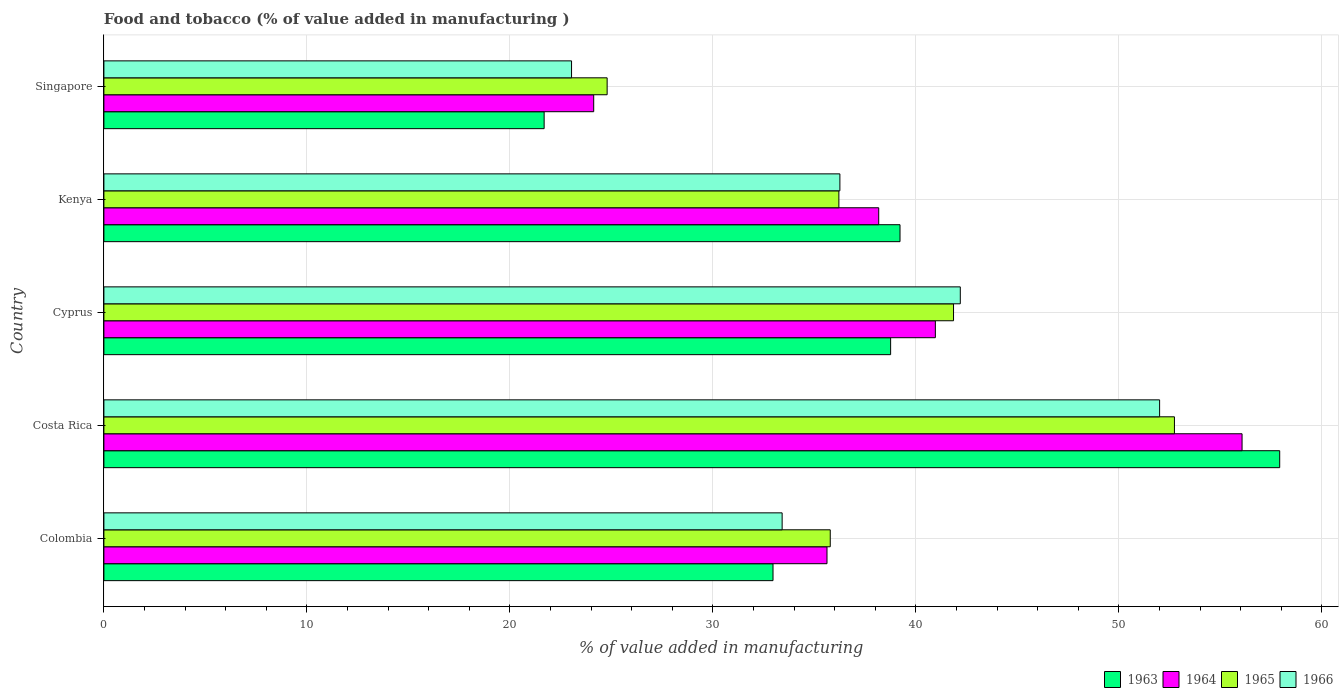How many groups of bars are there?
Provide a short and direct response. 5. How many bars are there on the 3rd tick from the top?
Keep it short and to the point. 4. How many bars are there on the 3rd tick from the bottom?
Provide a short and direct response. 4. What is the label of the 5th group of bars from the top?
Offer a very short reply. Colombia. In how many cases, is the number of bars for a given country not equal to the number of legend labels?
Offer a very short reply. 0. What is the value added in manufacturing food and tobacco in 1965 in Costa Rica?
Your answer should be compact. 52.73. Across all countries, what is the maximum value added in manufacturing food and tobacco in 1965?
Your answer should be compact. 52.73. Across all countries, what is the minimum value added in manufacturing food and tobacco in 1965?
Provide a short and direct response. 24.79. In which country was the value added in manufacturing food and tobacco in 1966 maximum?
Ensure brevity in your answer.  Costa Rica. In which country was the value added in manufacturing food and tobacco in 1963 minimum?
Your answer should be compact. Singapore. What is the total value added in manufacturing food and tobacco in 1963 in the graph?
Your answer should be compact. 190.54. What is the difference between the value added in manufacturing food and tobacco in 1965 in Colombia and that in Cyprus?
Offer a very short reply. -6.07. What is the difference between the value added in manufacturing food and tobacco in 1966 in Kenya and the value added in manufacturing food and tobacco in 1963 in Singapore?
Make the answer very short. 14.57. What is the average value added in manufacturing food and tobacco in 1965 per country?
Offer a terse response. 38.27. What is the difference between the value added in manufacturing food and tobacco in 1966 and value added in manufacturing food and tobacco in 1963 in Colombia?
Provide a succinct answer. 0.45. In how many countries, is the value added in manufacturing food and tobacco in 1963 greater than 46 %?
Your answer should be compact. 1. What is the ratio of the value added in manufacturing food and tobacco in 1965 in Colombia to that in Singapore?
Make the answer very short. 1.44. What is the difference between the highest and the second highest value added in manufacturing food and tobacco in 1966?
Offer a terse response. 9.82. What is the difference between the highest and the lowest value added in manufacturing food and tobacco in 1966?
Give a very brief answer. 28.97. What does the 2nd bar from the top in Costa Rica represents?
Ensure brevity in your answer.  1965. What does the 3rd bar from the bottom in Singapore represents?
Provide a succinct answer. 1965. Is it the case that in every country, the sum of the value added in manufacturing food and tobacco in 1966 and value added in manufacturing food and tobacco in 1963 is greater than the value added in manufacturing food and tobacco in 1964?
Ensure brevity in your answer.  Yes. How many countries are there in the graph?
Your response must be concise. 5. Are the values on the major ticks of X-axis written in scientific E-notation?
Offer a very short reply. No. Does the graph contain any zero values?
Your response must be concise. No. Does the graph contain grids?
Ensure brevity in your answer.  Yes. How are the legend labels stacked?
Give a very brief answer. Horizontal. What is the title of the graph?
Ensure brevity in your answer.  Food and tobacco (% of value added in manufacturing ). What is the label or title of the X-axis?
Ensure brevity in your answer.  % of value added in manufacturing. What is the label or title of the Y-axis?
Offer a terse response. Country. What is the % of value added in manufacturing of 1963 in Colombia?
Give a very brief answer. 32.96. What is the % of value added in manufacturing in 1964 in Colombia?
Provide a succinct answer. 35.62. What is the % of value added in manufacturing of 1965 in Colombia?
Offer a terse response. 35.78. What is the % of value added in manufacturing in 1966 in Colombia?
Your answer should be compact. 33.41. What is the % of value added in manufacturing of 1963 in Costa Rica?
Ensure brevity in your answer.  57.92. What is the % of value added in manufacturing of 1964 in Costa Rica?
Provide a short and direct response. 56.07. What is the % of value added in manufacturing of 1965 in Costa Rica?
Offer a very short reply. 52.73. What is the % of value added in manufacturing in 1966 in Costa Rica?
Provide a short and direct response. 52. What is the % of value added in manufacturing of 1963 in Cyprus?
Your answer should be very brief. 38.75. What is the % of value added in manufacturing of 1964 in Cyprus?
Your response must be concise. 40.96. What is the % of value added in manufacturing of 1965 in Cyprus?
Provide a succinct answer. 41.85. What is the % of value added in manufacturing in 1966 in Cyprus?
Provide a short and direct response. 42.19. What is the % of value added in manufacturing of 1963 in Kenya?
Provide a succinct answer. 39.22. What is the % of value added in manufacturing in 1964 in Kenya?
Your answer should be very brief. 38.17. What is the % of value added in manufacturing in 1965 in Kenya?
Give a very brief answer. 36.2. What is the % of value added in manufacturing in 1966 in Kenya?
Keep it short and to the point. 36.25. What is the % of value added in manufacturing in 1963 in Singapore?
Offer a terse response. 21.69. What is the % of value added in manufacturing of 1964 in Singapore?
Provide a succinct answer. 24.13. What is the % of value added in manufacturing in 1965 in Singapore?
Keep it short and to the point. 24.79. What is the % of value added in manufacturing of 1966 in Singapore?
Provide a succinct answer. 23.04. Across all countries, what is the maximum % of value added in manufacturing in 1963?
Offer a terse response. 57.92. Across all countries, what is the maximum % of value added in manufacturing of 1964?
Make the answer very short. 56.07. Across all countries, what is the maximum % of value added in manufacturing of 1965?
Provide a succinct answer. 52.73. Across all countries, what is the maximum % of value added in manufacturing in 1966?
Give a very brief answer. 52. Across all countries, what is the minimum % of value added in manufacturing in 1963?
Your response must be concise. 21.69. Across all countries, what is the minimum % of value added in manufacturing of 1964?
Provide a short and direct response. 24.13. Across all countries, what is the minimum % of value added in manufacturing in 1965?
Provide a succinct answer. 24.79. Across all countries, what is the minimum % of value added in manufacturing of 1966?
Offer a very short reply. 23.04. What is the total % of value added in manufacturing of 1963 in the graph?
Make the answer very short. 190.54. What is the total % of value added in manufacturing in 1964 in the graph?
Offer a very short reply. 194.94. What is the total % of value added in manufacturing in 1965 in the graph?
Give a very brief answer. 191.36. What is the total % of value added in manufacturing in 1966 in the graph?
Provide a short and direct response. 186.89. What is the difference between the % of value added in manufacturing of 1963 in Colombia and that in Costa Rica?
Offer a terse response. -24.96. What is the difference between the % of value added in manufacturing of 1964 in Colombia and that in Costa Rica?
Provide a short and direct response. -20.45. What is the difference between the % of value added in manufacturing of 1965 in Colombia and that in Costa Rica?
Give a very brief answer. -16.95. What is the difference between the % of value added in manufacturing in 1966 in Colombia and that in Costa Rica?
Your answer should be compact. -18.59. What is the difference between the % of value added in manufacturing in 1963 in Colombia and that in Cyprus?
Your response must be concise. -5.79. What is the difference between the % of value added in manufacturing in 1964 in Colombia and that in Cyprus?
Your answer should be compact. -5.34. What is the difference between the % of value added in manufacturing of 1965 in Colombia and that in Cyprus?
Your answer should be compact. -6.07. What is the difference between the % of value added in manufacturing in 1966 in Colombia and that in Cyprus?
Provide a short and direct response. -8.78. What is the difference between the % of value added in manufacturing in 1963 in Colombia and that in Kenya?
Your response must be concise. -6.26. What is the difference between the % of value added in manufacturing in 1964 in Colombia and that in Kenya?
Keep it short and to the point. -2.55. What is the difference between the % of value added in manufacturing in 1965 in Colombia and that in Kenya?
Your response must be concise. -0.42. What is the difference between the % of value added in manufacturing in 1966 in Colombia and that in Kenya?
Provide a succinct answer. -2.84. What is the difference between the % of value added in manufacturing in 1963 in Colombia and that in Singapore?
Give a very brief answer. 11.27. What is the difference between the % of value added in manufacturing of 1964 in Colombia and that in Singapore?
Your answer should be very brief. 11.49. What is the difference between the % of value added in manufacturing in 1965 in Colombia and that in Singapore?
Offer a terse response. 10.99. What is the difference between the % of value added in manufacturing in 1966 in Colombia and that in Singapore?
Offer a very short reply. 10.37. What is the difference between the % of value added in manufacturing of 1963 in Costa Rica and that in Cyprus?
Offer a terse response. 19.17. What is the difference between the % of value added in manufacturing of 1964 in Costa Rica and that in Cyprus?
Ensure brevity in your answer.  15.11. What is the difference between the % of value added in manufacturing of 1965 in Costa Rica and that in Cyprus?
Ensure brevity in your answer.  10.88. What is the difference between the % of value added in manufacturing of 1966 in Costa Rica and that in Cyprus?
Ensure brevity in your answer.  9.82. What is the difference between the % of value added in manufacturing in 1963 in Costa Rica and that in Kenya?
Your answer should be very brief. 18.7. What is the difference between the % of value added in manufacturing of 1964 in Costa Rica and that in Kenya?
Ensure brevity in your answer.  17.9. What is the difference between the % of value added in manufacturing in 1965 in Costa Rica and that in Kenya?
Your answer should be very brief. 16.53. What is the difference between the % of value added in manufacturing of 1966 in Costa Rica and that in Kenya?
Make the answer very short. 15.75. What is the difference between the % of value added in manufacturing of 1963 in Costa Rica and that in Singapore?
Your answer should be compact. 36.23. What is the difference between the % of value added in manufacturing of 1964 in Costa Rica and that in Singapore?
Offer a very short reply. 31.94. What is the difference between the % of value added in manufacturing in 1965 in Costa Rica and that in Singapore?
Your response must be concise. 27.94. What is the difference between the % of value added in manufacturing in 1966 in Costa Rica and that in Singapore?
Your answer should be very brief. 28.97. What is the difference between the % of value added in manufacturing of 1963 in Cyprus and that in Kenya?
Make the answer very short. -0.46. What is the difference between the % of value added in manufacturing in 1964 in Cyprus and that in Kenya?
Your answer should be very brief. 2.79. What is the difference between the % of value added in manufacturing of 1965 in Cyprus and that in Kenya?
Keep it short and to the point. 5.65. What is the difference between the % of value added in manufacturing of 1966 in Cyprus and that in Kenya?
Keep it short and to the point. 5.93. What is the difference between the % of value added in manufacturing in 1963 in Cyprus and that in Singapore?
Ensure brevity in your answer.  17.07. What is the difference between the % of value added in manufacturing in 1964 in Cyprus and that in Singapore?
Your response must be concise. 16.83. What is the difference between the % of value added in manufacturing of 1965 in Cyprus and that in Singapore?
Keep it short and to the point. 17.06. What is the difference between the % of value added in manufacturing of 1966 in Cyprus and that in Singapore?
Give a very brief answer. 19.15. What is the difference between the % of value added in manufacturing in 1963 in Kenya and that in Singapore?
Your response must be concise. 17.53. What is the difference between the % of value added in manufacturing of 1964 in Kenya and that in Singapore?
Provide a short and direct response. 14.04. What is the difference between the % of value added in manufacturing of 1965 in Kenya and that in Singapore?
Keep it short and to the point. 11.41. What is the difference between the % of value added in manufacturing in 1966 in Kenya and that in Singapore?
Give a very brief answer. 13.22. What is the difference between the % of value added in manufacturing in 1963 in Colombia and the % of value added in manufacturing in 1964 in Costa Rica?
Your response must be concise. -23.11. What is the difference between the % of value added in manufacturing in 1963 in Colombia and the % of value added in manufacturing in 1965 in Costa Rica?
Your response must be concise. -19.77. What is the difference between the % of value added in manufacturing of 1963 in Colombia and the % of value added in manufacturing of 1966 in Costa Rica?
Ensure brevity in your answer.  -19.04. What is the difference between the % of value added in manufacturing in 1964 in Colombia and the % of value added in manufacturing in 1965 in Costa Rica?
Your response must be concise. -17.11. What is the difference between the % of value added in manufacturing of 1964 in Colombia and the % of value added in manufacturing of 1966 in Costa Rica?
Give a very brief answer. -16.38. What is the difference between the % of value added in manufacturing in 1965 in Colombia and the % of value added in manufacturing in 1966 in Costa Rica?
Your response must be concise. -16.22. What is the difference between the % of value added in manufacturing in 1963 in Colombia and the % of value added in manufacturing in 1964 in Cyprus?
Make the answer very short. -8. What is the difference between the % of value added in manufacturing of 1963 in Colombia and the % of value added in manufacturing of 1965 in Cyprus?
Make the answer very short. -8.89. What is the difference between the % of value added in manufacturing in 1963 in Colombia and the % of value added in manufacturing in 1966 in Cyprus?
Your answer should be compact. -9.23. What is the difference between the % of value added in manufacturing in 1964 in Colombia and the % of value added in manufacturing in 1965 in Cyprus?
Give a very brief answer. -6.23. What is the difference between the % of value added in manufacturing in 1964 in Colombia and the % of value added in manufacturing in 1966 in Cyprus?
Give a very brief answer. -6.57. What is the difference between the % of value added in manufacturing in 1965 in Colombia and the % of value added in manufacturing in 1966 in Cyprus?
Provide a succinct answer. -6.41. What is the difference between the % of value added in manufacturing of 1963 in Colombia and the % of value added in manufacturing of 1964 in Kenya?
Your answer should be compact. -5.21. What is the difference between the % of value added in manufacturing in 1963 in Colombia and the % of value added in manufacturing in 1965 in Kenya?
Offer a very short reply. -3.24. What is the difference between the % of value added in manufacturing in 1963 in Colombia and the % of value added in manufacturing in 1966 in Kenya?
Provide a succinct answer. -3.29. What is the difference between the % of value added in manufacturing of 1964 in Colombia and the % of value added in manufacturing of 1965 in Kenya?
Make the answer very short. -0.58. What is the difference between the % of value added in manufacturing in 1964 in Colombia and the % of value added in manufacturing in 1966 in Kenya?
Keep it short and to the point. -0.63. What is the difference between the % of value added in manufacturing of 1965 in Colombia and the % of value added in manufacturing of 1966 in Kenya?
Your response must be concise. -0.47. What is the difference between the % of value added in manufacturing of 1963 in Colombia and the % of value added in manufacturing of 1964 in Singapore?
Your answer should be very brief. 8.83. What is the difference between the % of value added in manufacturing in 1963 in Colombia and the % of value added in manufacturing in 1965 in Singapore?
Provide a short and direct response. 8.17. What is the difference between the % of value added in manufacturing of 1963 in Colombia and the % of value added in manufacturing of 1966 in Singapore?
Your response must be concise. 9.92. What is the difference between the % of value added in manufacturing in 1964 in Colombia and the % of value added in manufacturing in 1965 in Singapore?
Offer a very short reply. 10.83. What is the difference between the % of value added in manufacturing in 1964 in Colombia and the % of value added in manufacturing in 1966 in Singapore?
Keep it short and to the point. 12.58. What is the difference between the % of value added in manufacturing in 1965 in Colombia and the % of value added in manufacturing in 1966 in Singapore?
Provide a short and direct response. 12.74. What is the difference between the % of value added in manufacturing in 1963 in Costa Rica and the % of value added in manufacturing in 1964 in Cyprus?
Make the answer very short. 16.96. What is the difference between the % of value added in manufacturing of 1963 in Costa Rica and the % of value added in manufacturing of 1965 in Cyprus?
Keep it short and to the point. 16.07. What is the difference between the % of value added in manufacturing of 1963 in Costa Rica and the % of value added in manufacturing of 1966 in Cyprus?
Provide a short and direct response. 15.73. What is the difference between the % of value added in manufacturing in 1964 in Costa Rica and the % of value added in manufacturing in 1965 in Cyprus?
Provide a short and direct response. 14.21. What is the difference between the % of value added in manufacturing in 1964 in Costa Rica and the % of value added in manufacturing in 1966 in Cyprus?
Offer a terse response. 13.88. What is the difference between the % of value added in manufacturing in 1965 in Costa Rica and the % of value added in manufacturing in 1966 in Cyprus?
Provide a short and direct response. 10.55. What is the difference between the % of value added in manufacturing of 1963 in Costa Rica and the % of value added in manufacturing of 1964 in Kenya?
Offer a very short reply. 19.75. What is the difference between the % of value added in manufacturing of 1963 in Costa Rica and the % of value added in manufacturing of 1965 in Kenya?
Give a very brief answer. 21.72. What is the difference between the % of value added in manufacturing of 1963 in Costa Rica and the % of value added in manufacturing of 1966 in Kenya?
Your answer should be compact. 21.67. What is the difference between the % of value added in manufacturing in 1964 in Costa Rica and the % of value added in manufacturing in 1965 in Kenya?
Provide a short and direct response. 19.86. What is the difference between the % of value added in manufacturing in 1964 in Costa Rica and the % of value added in manufacturing in 1966 in Kenya?
Offer a very short reply. 19.81. What is the difference between the % of value added in manufacturing in 1965 in Costa Rica and the % of value added in manufacturing in 1966 in Kenya?
Make the answer very short. 16.48. What is the difference between the % of value added in manufacturing of 1963 in Costa Rica and the % of value added in manufacturing of 1964 in Singapore?
Give a very brief answer. 33.79. What is the difference between the % of value added in manufacturing of 1963 in Costa Rica and the % of value added in manufacturing of 1965 in Singapore?
Your answer should be very brief. 33.13. What is the difference between the % of value added in manufacturing of 1963 in Costa Rica and the % of value added in manufacturing of 1966 in Singapore?
Make the answer very short. 34.88. What is the difference between the % of value added in manufacturing of 1964 in Costa Rica and the % of value added in manufacturing of 1965 in Singapore?
Make the answer very short. 31.28. What is the difference between the % of value added in manufacturing of 1964 in Costa Rica and the % of value added in manufacturing of 1966 in Singapore?
Provide a short and direct response. 33.03. What is the difference between the % of value added in manufacturing in 1965 in Costa Rica and the % of value added in manufacturing in 1966 in Singapore?
Your response must be concise. 29.7. What is the difference between the % of value added in manufacturing of 1963 in Cyprus and the % of value added in manufacturing of 1964 in Kenya?
Your response must be concise. 0.59. What is the difference between the % of value added in manufacturing of 1963 in Cyprus and the % of value added in manufacturing of 1965 in Kenya?
Your answer should be very brief. 2.55. What is the difference between the % of value added in manufacturing in 1963 in Cyprus and the % of value added in manufacturing in 1966 in Kenya?
Offer a very short reply. 2.5. What is the difference between the % of value added in manufacturing in 1964 in Cyprus and the % of value added in manufacturing in 1965 in Kenya?
Provide a short and direct response. 4.75. What is the difference between the % of value added in manufacturing of 1964 in Cyprus and the % of value added in manufacturing of 1966 in Kenya?
Make the answer very short. 4.7. What is the difference between the % of value added in manufacturing in 1965 in Cyprus and the % of value added in manufacturing in 1966 in Kenya?
Provide a succinct answer. 5.6. What is the difference between the % of value added in manufacturing in 1963 in Cyprus and the % of value added in manufacturing in 1964 in Singapore?
Provide a succinct answer. 14.63. What is the difference between the % of value added in manufacturing of 1963 in Cyprus and the % of value added in manufacturing of 1965 in Singapore?
Offer a terse response. 13.96. What is the difference between the % of value added in manufacturing in 1963 in Cyprus and the % of value added in manufacturing in 1966 in Singapore?
Make the answer very short. 15.72. What is the difference between the % of value added in manufacturing of 1964 in Cyprus and the % of value added in manufacturing of 1965 in Singapore?
Your answer should be very brief. 16.17. What is the difference between the % of value added in manufacturing of 1964 in Cyprus and the % of value added in manufacturing of 1966 in Singapore?
Your response must be concise. 17.92. What is the difference between the % of value added in manufacturing in 1965 in Cyprus and the % of value added in manufacturing in 1966 in Singapore?
Keep it short and to the point. 18.82. What is the difference between the % of value added in manufacturing in 1963 in Kenya and the % of value added in manufacturing in 1964 in Singapore?
Make the answer very short. 15.09. What is the difference between the % of value added in manufacturing of 1963 in Kenya and the % of value added in manufacturing of 1965 in Singapore?
Provide a succinct answer. 14.43. What is the difference between the % of value added in manufacturing in 1963 in Kenya and the % of value added in manufacturing in 1966 in Singapore?
Ensure brevity in your answer.  16.18. What is the difference between the % of value added in manufacturing in 1964 in Kenya and the % of value added in manufacturing in 1965 in Singapore?
Your answer should be compact. 13.38. What is the difference between the % of value added in manufacturing of 1964 in Kenya and the % of value added in manufacturing of 1966 in Singapore?
Your response must be concise. 15.13. What is the difference between the % of value added in manufacturing in 1965 in Kenya and the % of value added in manufacturing in 1966 in Singapore?
Your answer should be compact. 13.17. What is the average % of value added in manufacturing of 1963 per country?
Keep it short and to the point. 38.11. What is the average % of value added in manufacturing in 1964 per country?
Keep it short and to the point. 38.99. What is the average % of value added in manufacturing in 1965 per country?
Offer a terse response. 38.27. What is the average % of value added in manufacturing of 1966 per country?
Provide a short and direct response. 37.38. What is the difference between the % of value added in manufacturing in 1963 and % of value added in manufacturing in 1964 in Colombia?
Offer a very short reply. -2.66. What is the difference between the % of value added in manufacturing in 1963 and % of value added in manufacturing in 1965 in Colombia?
Provide a succinct answer. -2.82. What is the difference between the % of value added in manufacturing of 1963 and % of value added in manufacturing of 1966 in Colombia?
Offer a very short reply. -0.45. What is the difference between the % of value added in manufacturing of 1964 and % of value added in manufacturing of 1965 in Colombia?
Your answer should be very brief. -0.16. What is the difference between the % of value added in manufacturing of 1964 and % of value added in manufacturing of 1966 in Colombia?
Provide a short and direct response. 2.21. What is the difference between the % of value added in manufacturing of 1965 and % of value added in manufacturing of 1966 in Colombia?
Keep it short and to the point. 2.37. What is the difference between the % of value added in manufacturing of 1963 and % of value added in manufacturing of 1964 in Costa Rica?
Your response must be concise. 1.85. What is the difference between the % of value added in manufacturing of 1963 and % of value added in manufacturing of 1965 in Costa Rica?
Your answer should be very brief. 5.19. What is the difference between the % of value added in manufacturing of 1963 and % of value added in manufacturing of 1966 in Costa Rica?
Offer a terse response. 5.92. What is the difference between the % of value added in manufacturing of 1964 and % of value added in manufacturing of 1965 in Costa Rica?
Offer a terse response. 3.33. What is the difference between the % of value added in manufacturing of 1964 and % of value added in manufacturing of 1966 in Costa Rica?
Your response must be concise. 4.06. What is the difference between the % of value added in manufacturing in 1965 and % of value added in manufacturing in 1966 in Costa Rica?
Offer a terse response. 0.73. What is the difference between the % of value added in manufacturing in 1963 and % of value added in manufacturing in 1964 in Cyprus?
Give a very brief answer. -2.2. What is the difference between the % of value added in manufacturing in 1963 and % of value added in manufacturing in 1965 in Cyprus?
Your answer should be very brief. -3.1. What is the difference between the % of value added in manufacturing of 1963 and % of value added in manufacturing of 1966 in Cyprus?
Provide a succinct answer. -3.43. What is the difference between the % of value added in manufacturing of 1964 and % of value added in manufacturing of 1965 in Cyprus?
Provide a succinct answer. -0.9. What is the difference between the % of value added in manufacturing of 1964 and % of value added in manufacturing of 1966 in Cyprus?
Offer a terse response. -1.23. What is the difference between the % of value added in manufacturing in 1963 and % of value added in manufacturing in 1964 in Kenya?
Ensure brevity in your answer.  1.05. What is the difference between the % of value added in manufacturing of 1963 and % of value added in manufacturing of 1965 in Kenya?
Ensure brevity in your answer.  3.01. What is the difference between the % of value added in manufacturing in 1963 and % of value added in manufacturing in 1966 in Kenya?
Provide a succinct answer. 2.96. What is the difference between the % of value added in manufacturing in 1964 and % of value added in manufacturing in 1965 in Kenya?
Ensure brevity in your answer.  1.96. What is the difference between the % of value added in manufacturing in 1964 and % of value added in manufacturing in 1966 in Kenya?
Offer a very short reply. 1.91. What is the difference between the % of value added in manufacturing in 1963 and % of value added in manufacturing in 1964 in Singapore?
Your answer should be very brief. -2.44. What is the difference between the % of value added in manufacturing in 1963 and % of value added in manufacturing in 1965 in Singapore?
Keep it short and to the point. -3.1. What is the difference between the % of value added in manufacturing of 1963 and % of value added in manufacturing of 1966 in Singapore?
Give a very brief answer. -1.35. What is the difference between the % of value added in manufacturing in 1964 and % of value added in manufacturing in 1965 in Singapore?
Ensure brevity in your answer.  -0.66. What is the difference between the % of value added in manufacturing in 1964 and % of value added in manufacturing in 1966 in Singapore?
Offer a very short reply. 1.09. What is the difference between the % of value added in manufacturing in 1965 and % of value added in manufacturing in 1966 in Singapore?
Give a very brief answer. 1.75. What is the ratio of the % of value added in manufacturing in 1963 in Colombia to that in Costa Rica?
Make the answer very short. 0.57. What is the ratio of the % of value added in manufacturing in 1964 in Colombia to that in Costa Rica?
Your answer should be compact. 0.64. What is the ratio of the % of value added in manufacturing in 1965 in Colombia to that in Costa Rica?
Provide a succinct answer. 0.68. What is the ratio of the % of value added in manufacturing in 1966 in Colombia to that in Costa Rica?
Make the answer very short. 0.64. What is the ratio of the % of value added in manufacturing of 1963 in Colombia to that in Cyprus?
Make the answer very short. 0.85. What is the ratio of the % of value added in manufacturing of 1964 in Colombia to that in Cyprus?
Your answer should be very brief. 0.87. What is the ratio of the % of value added in manufacturing of 1965 in Colombia to that in Cyprus?
Provide a succinct answer. 0.85. What is the ratio of the % of value added in manufacturing in 1966 in Colombia to that in Cyprus?
Offer a terse response. 0.79. What is the ratio of the % of value added in manufacturing in 1963 in Colombia to that in Kenya?
Keep it short and to the point. 0.84. What is the ratio of the % of value added in manufacturing of 1964 in Colombia to that in Kenya?
Provide a short and direct response. 0.93. What is the ratio of the % of value added in manufacturing in 1965 in Colombia to that in Kenya?
Offer a terse response. 0.99. What is the ratio of the % of value added in manufacturing in 1966 in Colombia to that in Kenya?
Make the answer very short. 0.92. What is the ratio of the % of value added in manufacturing in 1963 in Colombia to that in Singapore?
Offer a terse response. 1.52. What is the ratio of the % of value added in manufacturing of 1964 in Colombia to that in Singapore?
Offer a very short reply. 1.48. What is the ratio of the % of value added in manufacturing in 1965 in Colombia to that in Singapore?
Keep it short and to the point. 1.44. What is the ratio of the % of value added in manufacturing of 1966 in Colombia to that in Singapore?
Your answer should be compact. 1.45. What is the ratio of the % of value added in manufacturing in 1963 in Costa Rica to that in Cyprus?
Ensure brevity in your answer.  1.49. What is the ratio of the % of value added in manufacturing in 1964 in Costa Rica to that in Cyprus?
Give a very brief answer. 1.37. What is the ratio of the % of value added in manufacturing of 1965 in Costa Rica to that in Cyprus?
Your response must be concise. 1.26. What is the ratio of the % of value added in manufacturing of 1966 in Costa Rica to that in Cyprus?
Offer a terse response. 1.23. What is the ratio of the % of value added in manufacturing in 1963 in Costa Rica to that in Kenya?
Provide a short and direct response. 1.48. What is the ratio of the % of value added in manufacturing in 1964 in Costa Rica to that in Kenya?
Keep it short and to the point. 1.47. What is the ratio of the % of value added in manufacturing in 1965 in Costa Rica to that in Kenya?
Your answer should be very brief. 1.46. What is the ratio of the % of value added in manufacturing in 1966 in Costa Rica to that in Kenya?
Give a very brief answer. 1.43. What is the ratio of the % of value added in manufacturing of 1963 in Costa Rica to that in Singapore?
Keep it short and to the point. 2.67. What is the ratio of the % of value added in manufacturing in 1964 in Costa Rica to that in Singapore?
Your answer should be compact. 2.32. What is the ratio of the % of value added in manufacturing of 1965 in Costa Rica to that in Singapore?
Offer a terse response. 2.13. What is the ratio of the % of value added in manufacturing of 1966 in Costa Rica to that in Singapore?
Make the answer very short. 2.26. What is the ratio of the % of value added in manufacturing in 1964 in Cyprus to that in Kenya?
Offer a very short reply. 1.07. What is the ratio of the % of value added in manufacturing of 1965 in Cyprus to that in Kenya?
Offer a very short reply. 1.16. What is the ratio of the % of value added in manufacturing in 1966 in Cyprus to that in Kenya?
Give a very brief answer. 1.16. What is the ratio of the % of value added in manufacturing of 1963 in Cyprus to that in Singapore?
Provide a short and direct response. 1.79. What is the ratio of the % of value added in manufacturing of 1964 in Cyprus to that in Singapore?
Ensure brevity in your answer.  1.7. What is the ratio of the % of value added in manufacturing in 1965 in Cyprus to that in Singapore?
Your answer should be compact. 1.69. What is the ratio of the % of value added in manufacturing in 1966 in Cyprus to that in Singapore?
Offer a terse response. 1.83. What is the ratio of the % of value added in manufacturing of 1963 in Kenya to that in Singapore?
Offer a very short reply. 1.81. What is the ratio of the % of value added in manufacturing in 1964 in Kenya to that in Singapore?
Give a very brief answer. 1.58. What is the ratio of the % of value added in manufacturing in 1965 in Kenya to that in Singapore?
Provide a succinct answer. 1.46. What is the ratio of the % of value added in manufacturing in 1966 in Kenya to that in Singapore?
Make the answer very short. 1.57. What is the difference between the highest and the second highest % of value added in manufacturing in 1963?
Offer a very short reply. 18.7. What is the difference between the highest and the second highest % of value added in manufacturing of 1964?
Make the answer very short. 15.11. What is the difference between the highest and the second highest % of value added in manufacturing of 1965?
Your answer should be compact. 10.88. What is the difference between the highest and the second highest % of value added in manufacturing in 1966?
Your answer should be compact. 9.82. What is the difference between the highest and the lowest % of value added in manufacturing of 1963?
Your answer should be very brief. 36.23. What is the difference between the highest and the lowest % of value added in manufacturing of 1964?
Give a very brief answer. 31.94. What is the difference between the highest and the lowest % of value added in manufacturing of 1965?
Provide a short and direct response. 27.94. What is the difference between the highest and the lowest % of value added in manufacturing of 1966?
Keep it short and to the point. 28.97. 